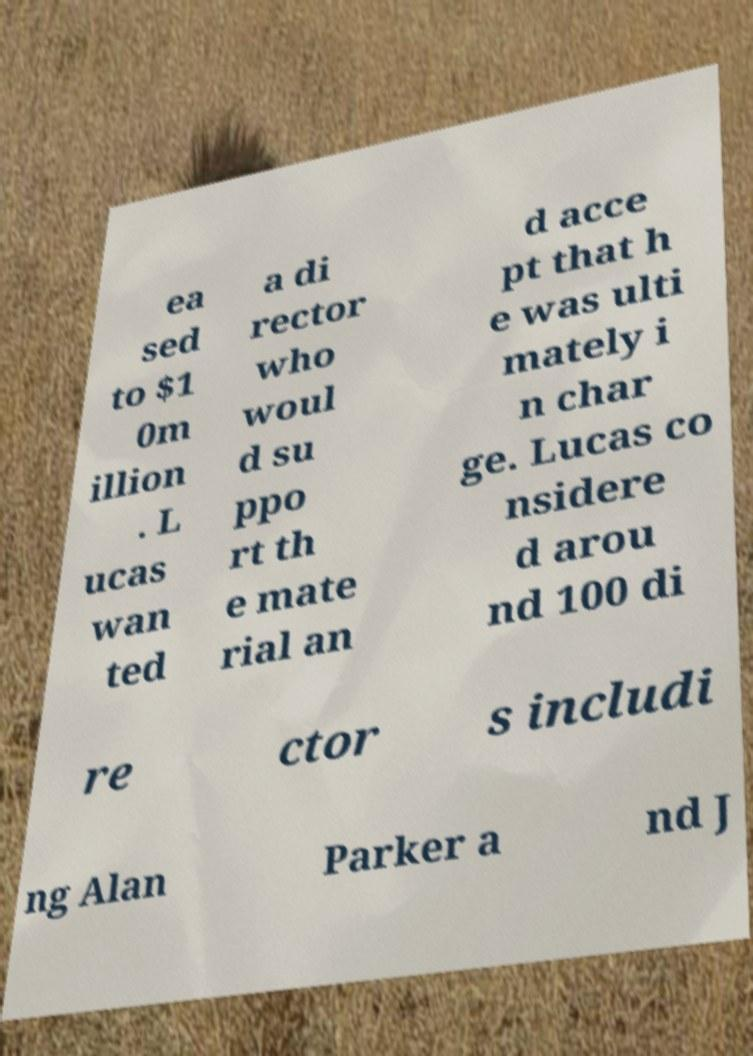Please identify and transcribe the text found in this image. ea sed to $1 0m illion . L ucas wan ted a di rector who woul d su ppo rt th e mate rial an d acce pt that h e was ulti mately i n char ge. Lucas co nsidere d arou nd 100 di re ctor s includi ng Alan Parker a nd J 